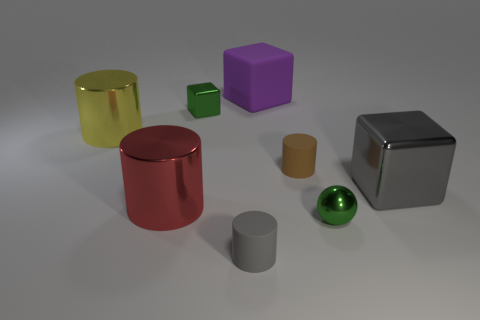Add 1 large purple metal cylinders. How many objects exist? 9 Subtract all spheres. How many objects are left? 7 Subtract all cyan balls. Subtract all large metal objects. How many objects are left? 5 Add 3 big metallic cylinders. How many big metallic cylinders are left? 5 Add 8 gray metal cubes. How many gray metal cubes exist? 9 Subtract 1 green balls. How many objects are left? 7 